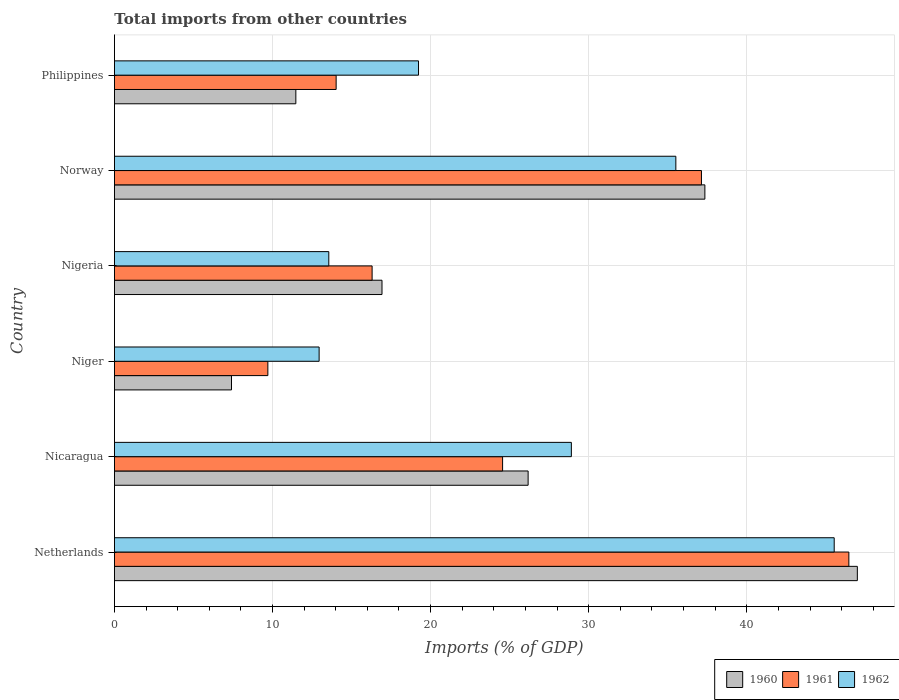How many groups of bars are there?
Provide a short and direct response. 6. Are the number of bars per tick equal to the number of legend labels?
Ensure brevity in your answer.  Yes. How many bars are there on the 6th tick from the top?
Make the answer very short. 3. How many bars are there on the 2nd tick from the bottom?
Your response must be concise. 3. What is the label of the 2nd group of bars from the top?
Keep it short and to the point. Norway. What is the total imports in 1960 in Nigeria?
Provide a succinct answer. 16.92. Across all countries, what is the maximum total imports in 1962?
Offer a very short reply. 45.53. Across all countries, what is the minimum total imports in 1961?
Give a very brief answer. 9.71. In which country was the total imports in 1962 minimum?
Ensure brevity in your answer.  Niger. What is the total total imports in 1960 in the graph?
Make the answer very short. 146.32. What is the difference between the total imports in 1962 in Niger and that in Philippines?
Your response must be concise. -6.29. What is the difference between the total imports in 1960 in Nicaragua and the total imports in 1962 in Nigeria?
Make the answer very short. 12.61. What is the average total imports in 1961 per country?
Offer a very short reply. 24.7. What is the difference between the total imports in 1961 and total imports in 1960 in Nigeria?
Make the answer very short. -0.63. What is the ratio of the total imports in 1961 in Netherlands to that in Philippines?
Give a very brief answer. 3.31. Is the total imports in 1961 in Netherlands less than that in Niger?
Provide a succinct answer. No. Is the difference between the total imports in 1961 in Netherlands and Philippines greater than the difference between the total imports in 1960 in Netherlands and Philippines?
Ensure brevity in your answer.  No. What is the difference between the highest and the second highest total imports in 1962?
Provide a succinct answer. 10.02. What is the difference between the highest and the lowest total imports in 1961?
Offer a terse response. 36.75. In how many countries, is the total imports in 1960 greater than the average total imports in 1960 taken over all countries?
Offer a very short reply. 3. Is the sum of the total imports in 1961 in Netherlands and Norway greater than the maximum total imports in 1960 across all countries?
Ensure brevity in your answer.  Yes. Is it the case that in every country, the sum of the total imports in 1962 and total imports in 1960 is greater than the total imports in 1961?
Your answer should be compact. Yes. Are all the bars in the graph horizontal?
Offer a very short reply. Yes. What is the difference between two consecutive major ticks on the X-axis?
Your answer should be compact. 10. Does the graph contain grids?
Offer a terse response. Yes. How are the legend labels stacked?
Provide a short and direct response. Horizontal. What is the title of the graph?
Provide a succinct answer. Total imports from other countries. What is the label or title of the X-axis?
Your answer should be very brief. Imports (% of GDP). What is the label or title of the Y-axis?
Offer a terse response. Country. What is the Imports (% of GDP) of 1960 in Netherlands?
Offer a terse response. 46.99. What is the Imports (% of GDP) of 1961 in Netherlands?
Make the answer very short. 46.46. What is the Imports (% of GDP) in 1962 in Netherlands?
Offer a terse response. 45.53. What is the Imports (% of GDP) of 1960 in Nicaragua?
Your response must be concise. 26.17. What is the Imports (% of GDP) of 1961 in Nicaragua?
Offer a very short reply. 24.55. What is the Imports (% of GDP) in 1962 in Nicaragua?
Your answer should be compact. 28.9. What is the Imports (% of GDP) in 1960 in Niger?
Provide a short and direct response. 7.41. What is the Imports (% of GDP) of 1961 in Niger?
Ensure brevity in your answer.  9.71. What is the Imports (% of GDP) of 1962 in Niger?
Ensure brevity in your answer.  12.95. What is the Imports (% of GDP) in 1960 in Nigeria?
Make the answer very short. 16.92. What is the Imports (% of GDP) of 1961 in Nigeria?
Your answer should be very brief. 16.3. What is the Imports (% of GDP) of 1962 in Nigeria?
Your answer should be very brief. 13.56. What is the Imports (% of GDP) in 1960 in Norway?
Offer a terse response. 37.35. What is the Imports (% of GDP) of 1961 in Norway?
Ensure brevity in your answer.  37.13. What is the Imports (% of GDP) in 1962 in Norway?
Keep it short and to the point. 35.51. What is the Imports (% of GDP) of 1960 in Philippines?
Your answer should be very brief. 11.48. What is the Imports (% of GDP) in 1961 in Philippines?
Give a very brief answer. 14.02. What is the Imports (% of GDP) of 1962 in Philippines?
Make the answer very short. 19.23. Across all countries, what is the maximum Imports (% of GDP) in 1960?
Your answer should be very brief. 46.99. Across all countries, what is the maximum Imports (% of GDP) of 1961?
Your response must be concise. 46.46. Across all countries, what is the maximum Imports (% of GDP) of 1962?
Keep it short and to the point. 45.53. Across all countries, what is the minimum Imports (% of GDP) of 1960?
Keep it short and to the point. 7.41. Across all countries, what is the minimum Imports (% of GDP) of 1961?
Offer a very short reply. 9.71. Across all countries, what is the minimum Imports (% of GDP) in 1962?
Offer a terse response. 12.95. What is the total Imports (% of GDP) in 1960 in the graph?
Your answer should be compact. 146.32. What is the total Imports (% of GDP) in 1961 in the graph?
Offer a very short reply. 148.17. What is the total Imports (% of GDP) in 1962 in the graph?
Keep it short and to the point. 155.69. What is the difference between the Imports (% of GDP) in 1960 in Netherlands and that in Nicaragua?
Give a very brief answer. 20.82. What is the difference between the Imports (% of GDP) in 1961 in Netherlands and that in Nicaragua?
Your response must be concise. 21.9. What is the difference between the Imports (% of GDP) in 1962 in Netherlands and that in Nicaragua?
Ensure brevity in your answer.  16.63. What is the difference between the Imports (% of GDP) of 1960 in Netherlands and that in Niger?
Give a very brief answer. 39.59. What is the difference between the Imports (% of GDP) of 1961 in Netherlands and that in Niger?
Make the answer very short. 36.75. What is the difference between the Imports (% of GDP) of 1962 in Netherlands and that in Niger?
Your answer should be compact. 32.58. What is the difference between the Imports (% of GDP) of 1960 in Netherlands and that in Nigeria?
Give a very brief answer. 30.07. What is the difference between the Imports (% of GDP) of 1961 in Netherlands and that in Nigeria?
Give a very brief answer. 30.16. What is the difference between the Imports (% of GDP) of 1962 in Netherlands and that in Nigeria?
Provide a succinct answer. 31.97. What is the difference between the Imports (% of GDP) in 1960 in Netherlands and that in Norway?
Give a very brief answer. 9.64. What is the difference between the Imports (% of GDP) of 1961 in Netherlands and that in Norway?
Your answer should be compact. 9.32. What is the difference between the Imports (% of GDP) of 1962 in Netherlands and that in Norway?
Provide a succinct answer. 10.02. What is the difference between the Imports (% of GDP) of 1960 in Netherlands and that in Philippines?
Ensure brevity in your answer.  35.52. What is the difference between the Imports (% of GDP) in 1961 in Netherlands and that in Philippines?
Your answer should be compact. 32.43. What is the difference between the Imports (% of GDP) of 1962 in Netherlands and that in Philippines?
Make the answer very short. 26.29. What is the difference between the Imports (% of GDP) in 1960 in Nicaragua and that in Niger?
Your answer should be very brief. 18.76. What is the difference between the Imports (% of GDP) in 1961 in Nicaragua and that in Niger?
Provide a short and direct response. 14.85. What is the difference between the Imports (% of GDP) in 1962 in Nicaragua and that in Niger?
Provide a short and direct response. 15.96. What is the difference between the Imports (% of GDP) in 1960 in Nicaragua and that in Nigeria?
Give a very brief answer. 9.24. What is the difference between the Imports (% of GDP) of 1961 in Nicaragua and that in Nigeria?
Your answer should be very brief. 8.25. What is the difference between the Imports (% of GDP) in 1962 in Nicaragua and that in Nigeria?
Offer a very short reply. 15.34. What is the difference between the Imports (% of GDP) in 1960 in Nicaragua and that in Norway?
Give a very brief answer. -11.18. What is the difference between the Imports (% of GDP) of 1961 in Nicaragua and that in Norway?
Offer a terse response. -12.58. What is the difference between the Imports (% of GDP) of 1962 in Nicaragua and that in Norway?
Make the answer very short. -6.61. What is the difference between the Imports (% of GDP) of 1960 in Nicaragua and that in Philippines?
Your answer should be compact. 14.69. What is the difference between the Imports (% of GDP) in 1961 in Nicaragua and that in Philippines?
Offer a very short reply. 10.53. What is the difference between the Imports (% of GDP) in 1962 in Nicaragua and that in Philippines?
Give a very brief answer. 9.67. What is the difference between the Imports (% of GDP) in 1960 in Niger and that in Nigeria?
Keep it short and to the point. -9.52. What is the difference between the Imports (% of GDP) of 1961 in Niger and that in Nigeria?
Offer a terse response. -6.59. What is the difference between the Imports (% of GDP) of 1962 in Niger and that in Nigeria?
Your answer should be very brief. -0.61. What is the difference between the Imports (% of GDP) in 1960 in Niger and that in Norway?
Offer a terse response. -29.94. What is the difference between the Imports (% of GDP) in 1961 in Niger and that in Norway?
Your answer should be compact. -27.43. What is the difference between the Imports (% of GDP) of 1962 in Niger and that in Norway?
Keep it short and to the point. -22.56. What is the difference between the Imports (% of GDP) of 1960 in Niger and that in Philippines?
Your response must be concise. -4.07. What is the difference between the Imports (% of GDP) in 1961 in Niger and that in Philippines?
Offer a terse response. -4.32. What is the difference between the Imports (% of GDP) of 1962 in Niger and that in Philippines?
Give a very brief answer. -6.29. What is the difference between the Imports (% of GDP) in 1960 in Nigeria and that in Norway?
Your answer should be compact. -20.42. What is the difference between the Imports (% of GDP) of 1961 in Nigeria and that in Norway?
Offer a very short reply. -20.83. What is the difference between the Imports (% of GDP) in 1962 in Nigeria and that in Norway?
Give a very brief answer. -21.95. What is the difference between the Imports (% of GDP) in 1960 in Nigeria and that in Philippines?
Provide a short and direct response. 5.45. What is the difference between the Imports (% of GDP) of 1961 in Nigeria and that in Philippines?
Provide a succinct answer. 2.27. What is the difference between the Imports (% of GDP) of 1962 in Nigeria and that in Philippines?
Keep it short and to the point. -5.67. What is the difference between the Imports (% of GDP) of 1960 in Norway and that in Philippines?
Your answer should be very brief. 25.87. What is the difference between the Imports (% of GDP) of 1961 in Norway and that in Philippines?
Ensure brevity in your answer.  23.11. What is the difference between the Imports (% of GDP) in 1962 in Norway and that in Philippines?
Your answer should be compact. 16.28. What is the difference between the Imports (% of GDP) of 1960 in Netherlands and the Imports (% of GDP) of 1961 in Nicaragua?
Ensure brevity in your answer.  22.44. What is the difference between the Imports (% of GDP) in 1960 in Netherlands and the Imports (% of GDP) in 1962 in Nicaragua?
Offer a very short reply. 18.09. What is the difference between the Imports (% of GDP) in 1961 in Netherlands and the Imports (% of GDP) in 1962 in Nicaragua?
Give a very brief answer. 17.55. What is the difference between the Imports (% of GDP) in 1960 in Netherlands and the Imports (% of GDP) in 1961 in Niger?
Your answer should be very brief. 37.29. What is the difference between the Imports (% of GDP) of 1960 in Netherlands and the Imports (% of GDP) of 1962 in Niger?
Keep it short and to the point. 34.05. What is the difference between the Imports (% of GDP) in 1961 in Netherlands and the Imports (% of GDP) in 1962 in Niger?
Keep it short and to the point. 33.51. What is the difference between the Imports (% of GDP) of 1960 in Netherlands and the Imports (% of GDP) of 1961 in Nigeria?
Your answer should be compact. 30.69. What is the difference between the Imports (% of GDP) in 1960 in Netherlands and the Imports (% of GDP) in 1962 in Nigeria?
Keep it short and to the point. 33.43. What is the difference between the Imports (% of GDP) of 1961 in Netherlands and the Imports (% of GDP) of 1962 in Nigeria?
Your answer should be very brief. 32.9. What is the difference between the Imports (% of GDP) in 1960 in Netherlands and the Imports (% of GDP) in 1961 in Norway?
Your answer should be compact. 9.86. What is the difference between the Imports (% of GDP) of 1960 in Netherlands and the Imports (% of GDP) of 1962 in Norway?
Offer a terse response. 11.48. What is the difference between the Imports (% of GDP) in 1961 in Netherlands and the Imports (% of GDP) in 1962 in Norway?
Provide a succinct answer. 10.94. What is the difference between the Imports (% of GDP) in 1960 in Netherlands and the Imports (% of GDP) in 1961 in Philippines?
Provide a succinct answer. 32.97. What is the difference between the Imports (% of GDP) of 1960 in Netherlands and the Imports (% of GDP) of 1962 in Philippines?
Ensure brevity in your answer.  27.76. What is the difference between the Imports (% of GDP) in 1961 in Netherlands and the Imports (% of GDP) in 1962 in Philippines?
Your answer should be very brief. 27.22. What is the difference between the Imports (% of GDP) in 1960 in Nicaragua and the Imports (% of GDP) in 1961 in Niger?
Offer a very short reply. 16.46. What is the difference between the Imports (% of GDP) of 1960 in Nicaragua and the Imports (% of GDP) of 1962 in Niger?
Offer a terse response. 13.22. What is the difference between the Imports (% of GDP) in 1961 in Nicaragua and the Imports (% of GDP) in 1962 in Niger?
Your response must be concise. 11.61. What is the difference between the Imports (% of GDP) in 1960 in Nicaragua and the Imports (% of GDP) in 1961 in Nigeria?
Ensure brevity in your answer.  9.87. What is the difference between the Imports (% of GDP) of 1960 in Nicaragua and the Imports (% of GDP) of 1962 in Nigeria?
Provide a short and direct response. 12.61. What is the difference between the Imports (% of GDP) in 1961 in Nicaragua and the Imports (% of GDP) in 1962 in Nigeria?
Make the answer very short. 10.99. What is the difference between the Imports (% of GDP) of 1960 in Nicaragua and the Imports (% of GDP) of 1961 in Norway?
Give a very brief answer. -10.96. What is the difference between the Imports (% of GDP) of 1960 in Nicaragua and the Imports (% of GDP) of 1962 in Norway?
Make the answer very short. -9.34. What is the difference between the Imports (% of GDP) of 1961 in Nicaragua and the Imports (% of GDP) of 1962 in Norway?
Your answer should be compact. -10.96. What is the difference between the Imports (% of GDP) in 1960 in Nicaragua and the Imports (% of GDP) in 1961 in Philippines?
Give a very brief answer. 12.14. What is the difference between the Imports (% of GDP) in 1960 in Nicaragua and the Imports (% of GDP) in 1962 in Philippines?
Give a very brief answer. 6.93. What is the difference between the Imports (% of GDP) of 1961 in Nicaragua and the Imports (% of GDP) of 1962 in Philippines?
Provide a short and direct response. 5.32. What is the difference between the Imports (% of GDP) of 1960 in Niger and the Imports (% of GDP) of 1961 in Nigeria?
Your response must be concise. -8.89. What is the difference between the Imports (% of GDP) in 1960 in Niger and the Imports (% of GDP) in 1962 in Nigeria?
Give a very brief answer. -6.16. What is the difference between the Imports (% of GDP) of 1961 in Niger and the Imports (% of GDP) of 1962 in Nigeria?
Give a very brief answer. -3.85. What is the difference between the Imports (% of GDP) of 1960 in Niger and the Imports (% of GDP) of 1961 in Norway?
Keep it short and to the point. -29.73. What is the difference between the Imports (% of GDP) of 1960 in Niger and the Imports (% of GDP) of 1962 in Norway?
Ensure brevity in your answer.  -28.11. What is the difference between the Imports (% of GDP) in 1961 in Niger and the Imports (% of GDP) in 1962 in Norway?
Provide a succinct answer. -25.81. What is the difference between the Imports (% of GDP) in 1960 in Niger and the Imports (% of GDP) in 1961 in Philippines?
Offer a terse response. -6.62. What is the difference between the Imports (% of GDP) in 1960 in Niger and the Imports (% of GDP) in 1962 in Philippines?
Your answer should be very brief. -11.83. What is the difference between the Imports (% of GDP) of 1961 in Niger and the Imports (% of GDP) of 1962 in Philippines?
Offer a very short reply. -9.53. What is the difference between the Imports (% of GDP) in 1960 in Nigeria and the Imports (% of GDP) in 1961 in Norway?
Give a very brief answer. -20.21. What is the difference between the Imports (% of GDP) of 1960 in Nigeria and the Imports (% of GDP) of 1962 in Norway?
Provide a short and direct response. -18.59. What is the difference between the Imports (% of GDP) in 1961 in Nigeria and the Imports (% of GDP) in 1962 in Norway?
Ensure brevity in your answer.  -19.21. What is the difference between the Imports (% of GDP) of 1960 in Nigeria and the Imports (% of GDP) of 1961 in Philippines?
Your answer should be compact. 2.9. What is the difference between the Imports (% of GDP) in 1960 in Nigeria and the Imports (% of GDP) in 1962 in Philippines?
Offer a terse response. -2.31. What is the difference between the Imports (% of GDP) in 1961 in Nigeria and the Imports (% of GDP) in 1962 in Philippines?
Provide a succinct answer. -2.93. What is the difference between the Imports (% of GDP) in 1960 in Norway and the Imports (% of GDP) in 1961 in Philippines?
Your response must be concise. 23.32. What is the difference between the Imports (% of GDP) in 1960 in Norway and the Imports (% of GDP) in 1962 in Philippines?
Keep it short and to the point. 18.11. What is the difference between the Imports (% of GDP) in 1961 in Norway and the Imports (% of GDP) in 1962 in Philippines?
Your answer should be compact. 17.9. What is the average Imports (% of GDP) of 1960 per country?
Your answer should be very brief. 24.39. What is the average Imports (% of GDP) in 1961 per country?
Your response must be concise. 24.7. What is the average Imports (% of GDP) of 1962 per country?
Your answer should be very brief. 25.95. What is the difference between the Imports (% of GDP) in 1960 and Imports (% of GDP) in 1961 in Netherlands?
Your response must be concise. 0.54. What is the difference between the Imports (% of GDP) of 1960 and Imports (% of GDP) of 1962 in Netherlands?
Provide a succinct answer. 1.46. What is the difference between the Imports (% of GDP) of 1961 and Imports (% of GDP) of 1962 in Netherlands?
Your response must be concise. 0.93. What is the difference between the Imports (% of GDP) in 1960 and Imports (% of GDP) in 1961 in Nicaragua?
Make the answer very short. 1.62. What is the difference between the Imports (% of GDP) in 1960 and Imports (% of GDP) in 1962 in Nicaragua?
Give a very brief answer. -2.73. What is the difference between the Imports (% of GDP) in 1961 and Imports (% of GDP) in 1962 in Nicaragua?
Make the answer very short. -4.35. What is the difference between the Imports (% of GDP) in 1960 and Imports (% of GDP) in 1961 in Niger?
Provide a succinct answer. -2.3. What is the difference between the Imports (% of GDP) of 1960 and Imports (% of GDP) of 1962 in Niger?
Your response must be concise. -5.54. What is the difference between the Imports (% of GDP) of 1961 and Imports (% of GDP) of 1962 in Niger?
Give a very brief answer. -3.24. What is the difference between the Imports (% of GDP) of 1960 and Imports (% of GDP) of 1961 in Nigeria?
Keep it short and to the point. 0.63. What is the difference between the Imports (% of GDP) of 1960 and Imports (% of GDP) of 1962 in Nigeria?
Keep it short and to the point. 3.36. What is the difference between the Imports (% of GDP) of 1961 and Imports (% of GDP) of 1962 in Nigeria?
Offer a terse response. 2.74. What is the difference between the Imports (% of GDP) of 1960 and Imports (% of GDP) of 1961 in Norway?
Make the answer very short. 0.22. What is the difference between the Imports (% of GDP) of 1960 and Imports (% of GDP) of 1962 in Norway?
Provide a short and direct response. 1.84. What is the difference between the Imports (% of GDP) of 1961 and Imports (% of GDP) of 1962 in Norway?
Give a very brief answer. 1.62. What is the difference between the Imports (% of GDP) of 1960 and Imports (% of GDP) of 1961 in Philippines?
Offer a terse response. -2.55. What is the difference between the Imports (% of GDP) in 1960 and Imports (% of GDP) in 1962 in Philippines?
Your answer should be very brief. -7.76. What is the difference between the Imports (% of GDP) in 1961 and Imports (% of GDP) in 1962 in Philippines?
Provide a succinct answer. -5.21. What is the ratio of the Imports (% of GDP) in 1960 in Netherlands to that in Nicaragua?
Your answer should be compact. 1.8. What is the ratio of the Imports (% of GDP) of 1961 in Netherlands to that in Nicaragua?
Offer a very short reply. 1.89. What is the ratio of the Imports (% of GDP) in 1962 in Netherlands to that in Nicaragua?
Offer a terse response. 1.58. What is the ratio of the Imports (% of GDP) in 1960 in Netherlands to that in Niger?
Offer a terse response. 6.35. What is the ratio of the Imports (% of GDP) of 1961 in Netherlands to that in Niger?
Your answer should be compact. 4.79. What is the ratio of the Imports (% of GDP) of 1962 in Netherlands to that in Niger?
Your answer should be very brief. 3.52. What is the ratio of the Imports (% of GDP) of 1960 in Netherlands to that in Nigeria?
Keep it short and to the point. 2.78. What is the ratio of the Imports (% of GDP) in 1961 in Netherlands to that in Nigeria?
Your response must be concise. 2.85. What is the ratio of the Imports (% of GDP) in 1962 in Netherlands to that in Nigeria?
Provide a succinct answer. 3.36. What is the ratio of the Imports (% of GDP) in 1960 in Netherlands to that in Norway?
Keep it short and to the point. 1.26. What is the ratio of the Imports (% of GDP) in 1961 in Netherlands to that in Norway?
Ensure brevity in your answer.  1.25. What is the ratio of the Imports (% of GDP) of 1962 in Netherlands to that in Norway?
Your response must be concise. 1.28. What is the ratio of the Imports (% of GDP) of 1960 in Netherlands to that in Philippines?
Ensure brevity in your answer.  4.1. What is the ratio of the Imports (% of GDP) in 1961 in Netherlands to that in Philippines?
Ensure brevity in your answer.  3.31. What is the ratio of the Imports (% of GDP) in 1962 in Netherlands to that in Philippines?
Offer a very short reply. 2.37. What is the ratio of the Imports (% of GDP) of 1960 in Nicaragua to that in Niger?
Provide a short and direct response. 3.53. What is the ratio of the Imports (% of GDP) of 1961 in Nicaragua to that in Niger?
Provide a short and direct response. 2.53. What is the ratio of the Imports (% of GDP) of 1962 in Nicaragua to that in Niger?
Provide a short and direct response. 2.23. What is the ratio of the Imports (% of GDP) in 1960 in Nicaragua to that in Nigeria?
Make the answer very short. 1.55. What is the ratio of the Imports (% of GDP) in 1961 in Nicaragua to that in Nigeria?
Your response must be concise. 1.51. What is the ratio of the Imports (% of GDP) of 1962 in Nicaragua to that in Nigeria?
Make the answer very short. 2.13. What is the ratio of the Imports (% of GDP) of 1960 in Nicaragua to that in Norway?
Your response must be concise. 0.7. What is the ratio of the Imports (% of GDP) in 1961 in Nicaragua to that in Norway?
Provide a succinct answer. 0.66. What is the ratio of the Imports (% of GDP) in 1962 in Nicaragua to that in Norway?
Provide a short and direct response. 0.81. What is the ratio of the Imports (% of GDP) of 1960 in Nicaragua to that in Philippines?
Make the answer very short. 2.28. What is the ratio of the Imports (% of GDP) of 1961 in Nicaragua to that in Philippines?
Offer a terse response. 1.75. What is the ratio of the Imports (% of GDP) of 1962 in Nicaragua to that in Philippines?
Offer a terse response. 1.5. What is the ratio of the Imports (% of GDP) in 1960 in Niger to that in Nigeria?
Ensure brevity in your answer.  0.44. What is the ratio of the Imports (% of GDP) of 1961 in Niger to that in Nigeria?
Offer a very short reply. 0.6. What is the ratio of the Imports (% of GDP) of 1962 in Niger to that in Nigeria?
Keep it short and to the point. 0.95. What is the ratio of the Imports (% of GDP) of 1960 in Niger to that in Norway?
Your response must be concise. 0.2. What is the ratio of the Imports (% of GDP) of 1961 in Niger to that in Norway?
Your answer should be compact. 0.26. What is the ratio of the Imports (% of GDP) in 1962 in Niger to that in Norway?
Make the answer very short. 0.36. What is the ratio of the Imports (% of GDP) in 1960 in Niger to that in Philippines?
Give a very brief answer. 0.65. What is the ratio of the Imports (% of GDP) in 1961 in Niger to that in Philippines?
Give a very brief answer. 0.69. What is the ratio of the Imports (% of GDP) of 1962 in Niger to that in Philippines?
Provide a short and direct response. 0.67. What is the ratio of the Imports (% of GDP) in 1960 in Nigeria to that in Norway?
Make the answer very short. 0.45. What is the ratio of the Imports (% of GDP) of 1961 in Nigeria to that in Norway?
Offer a terse response. 0.44. What is the ratio of the Imports (% of GDP) in 1962 in Nigeria to that in Norway?
Provide a succinct answer. 0.38. What is the ratio of the Imports (% of GDP) of 1960 in Nigeria to that in Philippines?
Offer a very short reply. 1.47. What is the ratio of the Imports (% of GDP) of 1961 in Nigeria to that in Philippines?
Provide a succinct answer. 1.16. What is the ratio of the Imports (% of GDP) of 1962 in Nigeria to that in Philippines?
Your answer should be compact. 0.7. What is the ratio of the Imports (% of GDP) in 1960 in Norway to that in Philippines?
Ensure brevity in your answer.  3.25. What is the ratio of the Imports (% of GDP) of 1961 in Norway to that in Philippines?
Provide a succinct answer. 2.65. What is the ratio of the Imports (% of GDP) of 1962 in Norway to that in Philippines?
Give a very brief answer. 1.85. What is the difference between the highest and the second highest Imports (% of GDP) of 1960?
Ensure brevity in your answer.  9.64. What is the difference between the highest and the second highest Imports (% of GDP) in 1961?
Your response must be concise. 9.32. What is the difference between the highest and the second highest Imports (% of GDP) in 1962?
Offer a terse response. 10.02. What is the difference between the highest and the lowest Imports (% of GDP) of 1960?
Your response must be concise. 39.59. What is the difference between the highest and the lowest Imports (% of GDP) of 1961?
Your response must be concise. 36.75. What is the difference between the highest and the lowest Imports (% of GDP) in 1962?
Keep it short and to the point. 32.58. 